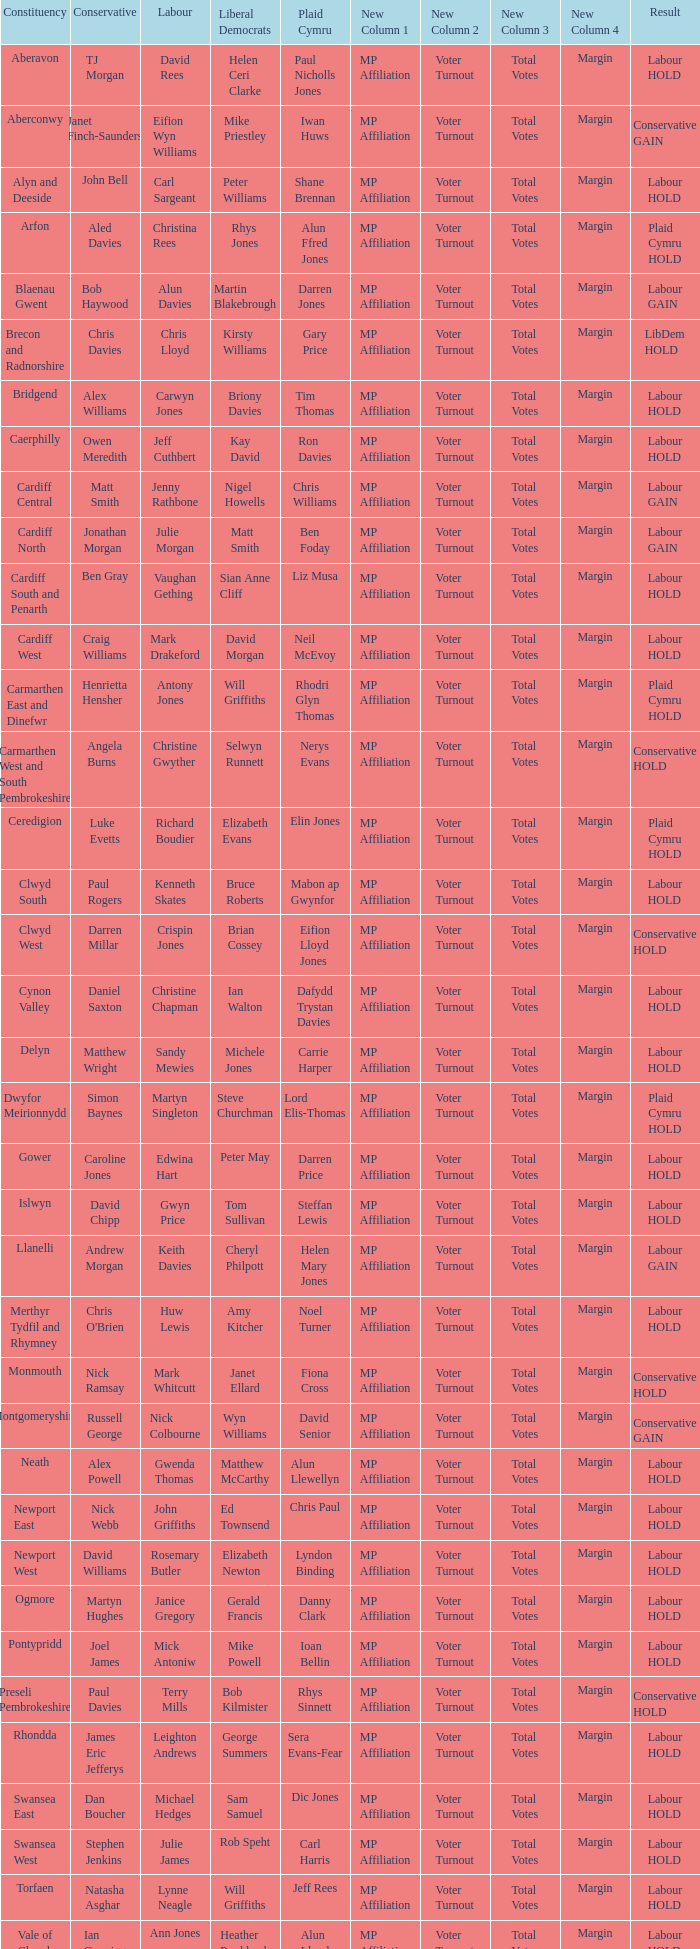What constituency does the Conservative Darren Millar belong to? Clwyd West. 